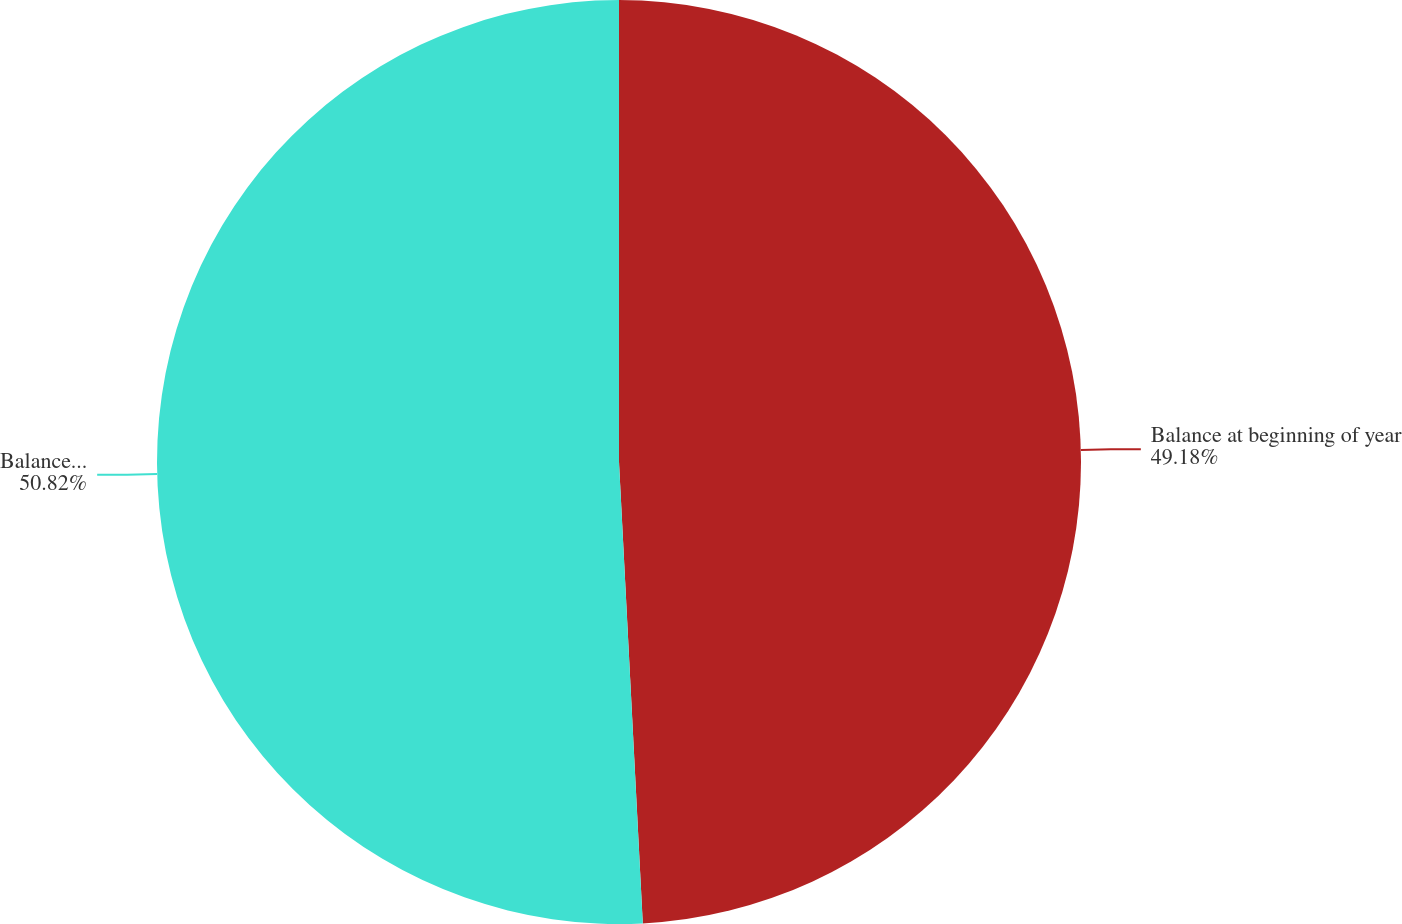Convert chart. <chart><loc_0><loc_0><loc_500><loc_500><pie_chart><fcel>Balance at beginning of year<fcel>Balance at end of year<nl><fcel>49.18%<fcel>50.82%<nl></chart> 